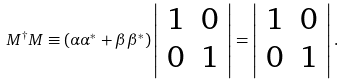Convert formula to latex. <formula><loc_0><loc_0><loc_500><loc_500>M ^ { \dagger } M \equiv ( \alpha \alpha ^ { * } + \beta \beta ^ { * } ) \left | \begin{array} { c c } 1 & 0 \\ 0 & 1 \end{array} \right | = \left | \begin{array} { c c } 1 & 0 \\ 0 & 1 \end{array} \right | .</formula> 